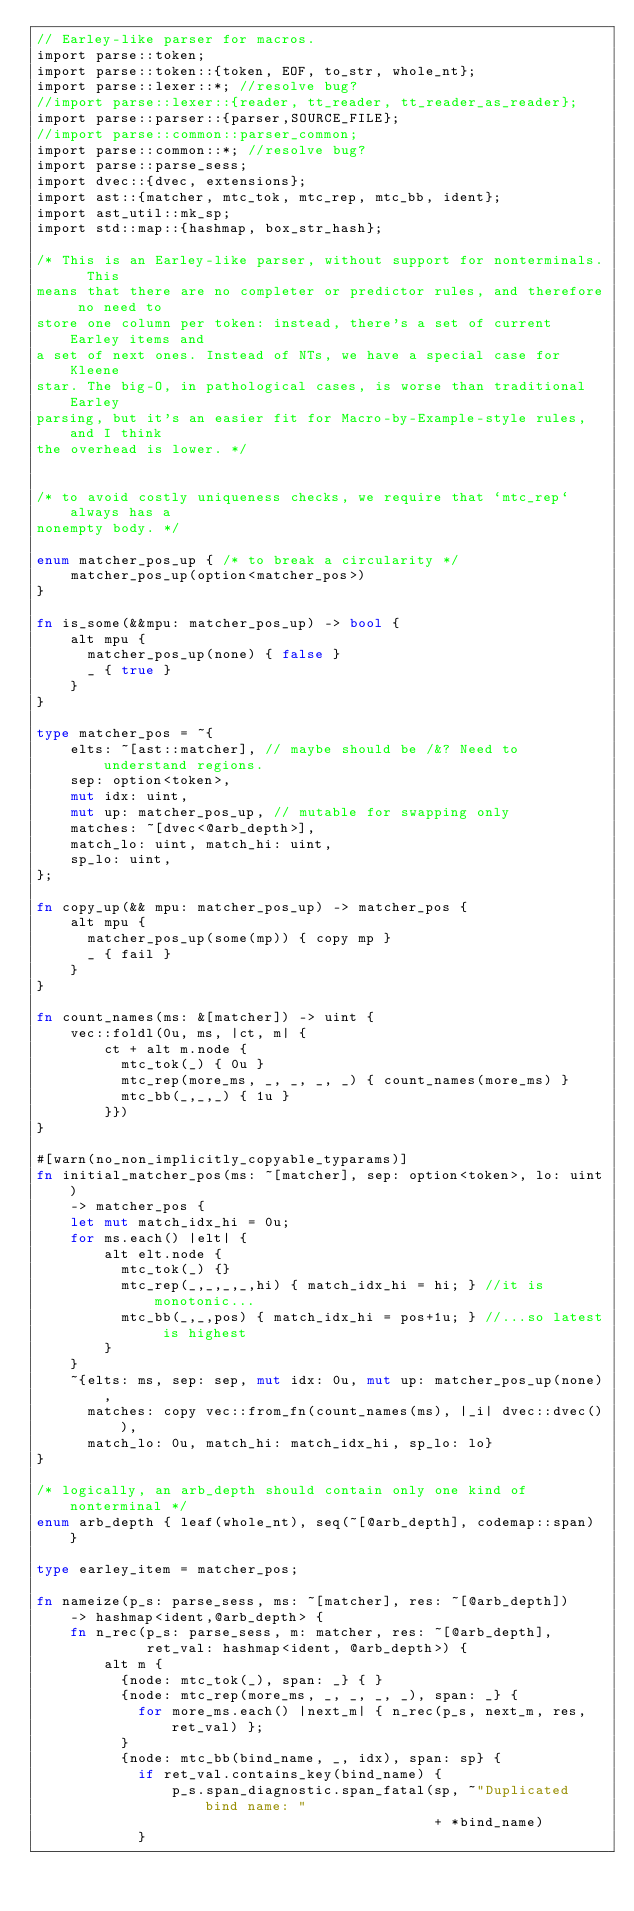Convert code to text. <code><loc_0><loc_0><loc_500><loc_500><_Rust_>// Earley-like parser for macros.
import parse::token;
import parse::token::{token, EOF, to_str, whole_nt};
import parse::lexer::*; //resolve bug?
//import parse::lexer::{reader, tt_reader, tt_reader_as_reader};
import parse::parser::{parser,SOURCE_FILE};
//import parse::common::parser_common;
import parse::common::*; //resolve bug?
import parse::parse_sess;
import dvec::{dvec, extensions};
import ast::{matcher, mtc_tok, mtc_rep, mtc_bb, ident};
import ast_util::mk_sp;
import std::map::{hashmap, box_str_hash};

/* This is an Earley-like parser, without support for nonterminals.  This
means that there are no completer or predictor rules, and therefore no need to
store one column per token: instead, there's a set of current Earley items and
a set of next ones. Instead of NTs, we have a special case for Kleene
star. The big-O, in pathological cases, is worse than traditional Earley
parsing, but it's an easier fit for Macro-by-Example-style rules, and I think
the overhead is lower. */


/* to avoid costly uniqueness checks, we require that `mtc_rep` always has a
nonempty body. */

enum matcher_pos_up { /* to break a circularity */
    matcher_pos_up(option<matcher_pos>)
}

fn is_some(&&mpu: matcher_pos_up) -> bool {
    alt mpu {
      matcher_pos_up(none) { false }
      _ { true }
    }
}

type matcher_pos = ~{
    elts: ~[ast::matcher], // maybe should be /&? Need to understand regions.
    sep: option<token>,
    mut idx: uint,
    mut up: matcher_pos_up, // mutable for swapping only
    matches: ~[dvec<@arb_depth>],
    match_lo: uint, match_hi: uint,
    sp_lo: uint,
};

fn copy_up(&& mpu: matcher_pos_up) -> matcher_pos {
    alt mpu {
      matcher_pos_up(some(mp)) { copy mp }
      _ { fail }
    }
}

fn count_names(ms: &[matcher]) -> uint {
    vec::foldl(0u, ms, |ct, m| {
        ct + alt m.node {
          mtc_tok(_) { 0u }
          mtc_rep(more_ms, _, _, _, _) { count_names(more_ms) }
          mtc_bb(_,_,_) { 1u }
        }})
}

#[warn(no_non_implicitly_copyable_typarams)]
fn initial_matcher_pos(ms: ~[matcher], sep: option<token>, lo: uint)
    -> matcher_pos {
    let mut match_idx_hi = 0u;
    for ms.each() |elt| {
        alt elt.node {
          mtc_tok(_) {}
          mtc_rep(_,_,_,_,hi) { match_idx_hi = hi; } //it is monotonic...
          mtc_bb(_,_,pos) { match_idx_hi = pos+1u; } //...so latest is highest
        }
    }
    ~{elts: ms, sep: sep, mut idx: 0u, mut up: matcher_pos_up(none),
      matches: copy vec::from_fn(count_names(ms), |_i| dvec::dvec()),
      match_lo: 0u, match_hi: match_idx_hi, sp_lo: lo}
}

/* logically, an arb_depth should contain only one kind of nonterminal */
enum arb_depth { leaf(whole_nt), seq(~[@arb_depth], codemap::span) }

type earley_item = matcher_pos;

fn nameize(p_s: parse_sess, ms: ~[matcher], res: ~[@arb_depth])
    -> hashmap<ident,@arb_depth> {
    fn n_rec(p_s: parse_sess, m: matcher, res: ~[@arb_depth],
             ret_val: hashmap<ident, @arb_depth>) {
        alt m {
          {node: mtc_tok(_), span: _} { }
          {node: mtc_rep(more_ms, _, _, _, _), span: _} {
            for more_ms.each() |next_m| { n_rec(p_s, next_m, res, ret_val) };
          }
          {node: mtc_bb(bind_name, _, idx), span: sp} {
            if ret_val.contains_key(bind_name) {
                p_s.span_diagnostic.span_fatal(sp, ~"Duplicated bind name: "
                                               + *bind_name)
            }</code> 